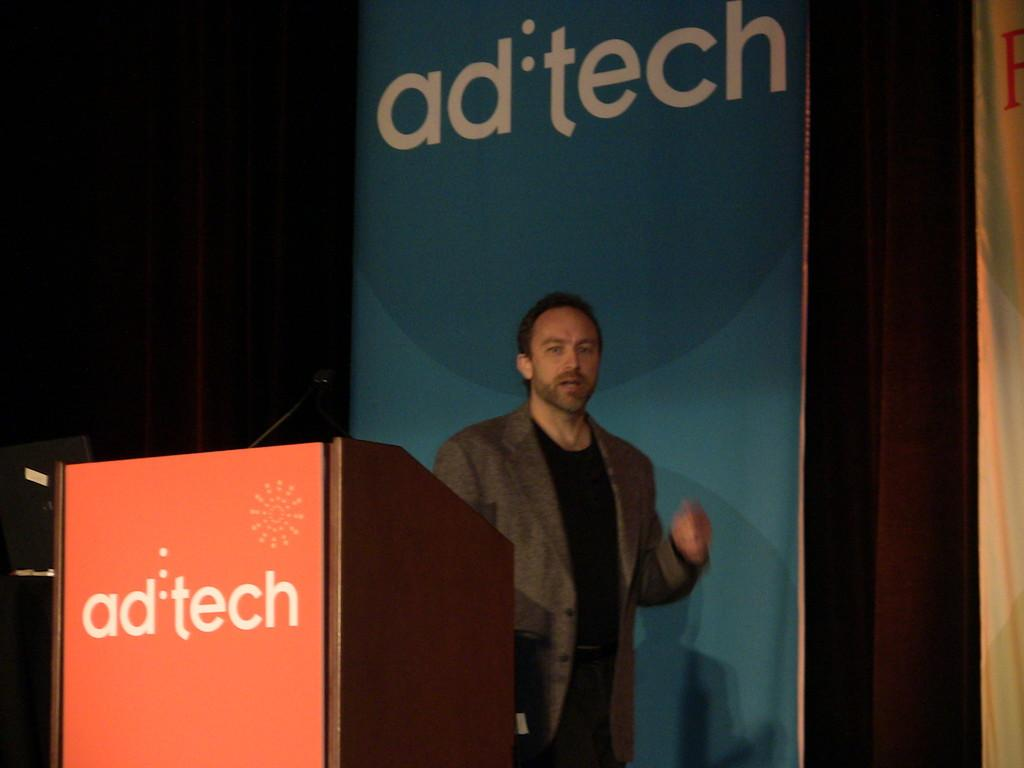What is located in the foreground of the image? There is a person and a microphone (mic) in the foreground of the image. What object is present on the desk in the foreground of the image? The desk in the foreground of the image is not mentioned in the facts, so we cannot determine what objects are on it. What can be seen in the background of the image? There are posters and a curtain in the background of the image. What type of cake is being served to the governor in the image? There is no governor or cake present in the image. How many icicles are hanging from the curtain in the image? There are no icicles present in the image; only a curtain is mentioned in the background. 